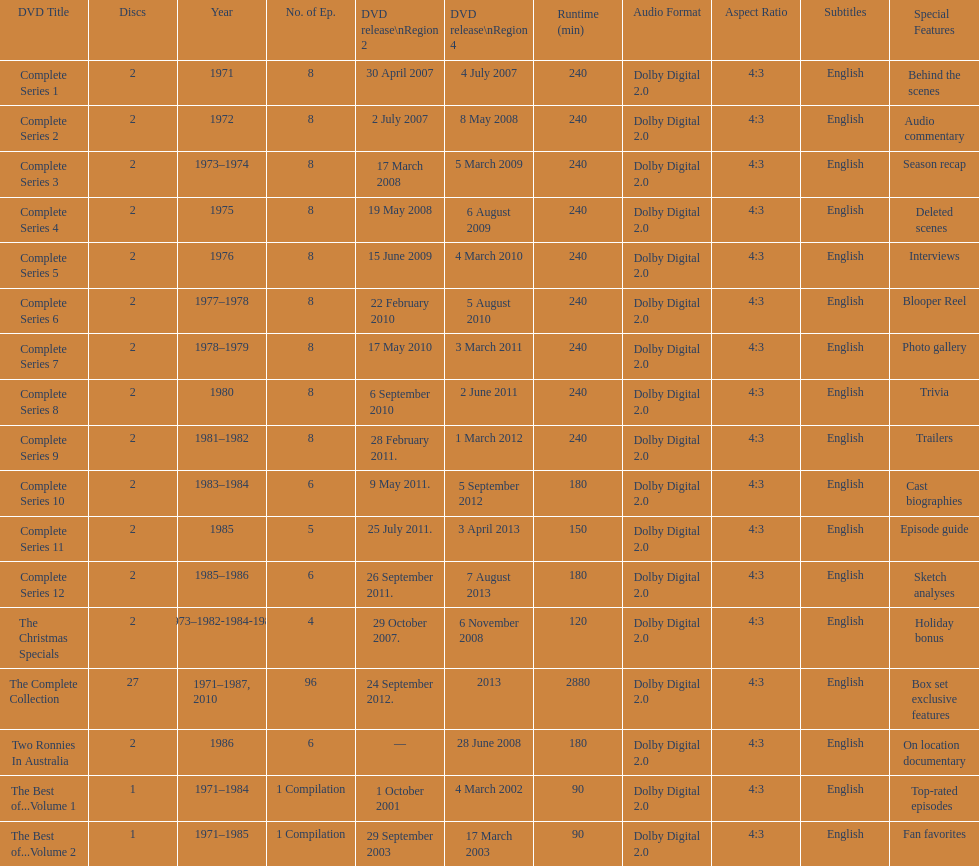The complete collection has 96 episodes, but the christmas specials only has how many episodes? 4. Would you be able to parse every entry in this table? {'header': ['DVD Title', 'Discs', 'Year', 'No. of Ep.', 'DVD release\\nRegion 2', 'DVD release\\nRegion 4', 'Runtime (min)', 'Audio Format', 'Aspect Ratio', 'Subtitles', 'Special Features'], 'rows': [['Complete Series 1', '2', '1971', '8', '30 April 2007', '4 July 2007', '240', 'Dolby Digital 2.0', '4:3', 'English', 'Behind the scenes'], ['Complete Series 2', '2', '1972', '8', '2 July 2007', '8 May 2008', '240', 'Dolby Digital 2.0', '4:3', 'English', 'Audio commentary'], ['Complete Series 3', '2', '1973–1974', '8', '17 March 2008', '5 March 2009', '240', 'Dolby Digital 2.0', '4:3', 'English', 'Season recap'], ['Complete Series 4', '2', '1975', '8', '19 May 2008', '6 August 2009', '240', 'Dolby Digital 2.0', '4:3', 'English', 'Deleted scenes'], ['Complete Series 5', '2', '1976', '8', '15 June 2009', '4 March 2010', '240', 'Dolby Digital 2.0', '4:3', 'English', 'Interviews'], ['Complete Series 6', '2', '1977–1978', '8', '22 February 2010', '5 August 2010', '240', 'Dolby Digital 2.0', '4:3', 'English', 'Blooper Reel'], ['Complete Series 7', '2', '1978–1979', '8', '17 May 2010', '3 March 2011', '240', 'Dolby Digital 2.0', '4:3', 'English', 'Photo gallery'], ['Complete Series 8', '2', '1980', '8', '6 September 2010', '2 June 2011', '240', 'Dolby Digital 2.0', '4:3', 'English', 'Trivia'], ['Complete Series 9', '2', '1981–1982', '8', '28 February 2011.', '1 March 2012', '240', 'Dolby Digital 2.0', '4:3', 'English', 'Trailers'], ['Complete Series 10', '2', '1983–1984', '6', '9 May 2011.', '5 September 2012', '180', 'Dolby Digital 2.0', '4:3', 'English', 'Cast biographies'], ['Complete Series 11', '2', '1985', '5', '25 July 2011.', '3 April 2013', '150', 'Dolby Digital 2.0', '4:3', 'English', 'Episode guide'], ['Complete Series 12', '2', '1985–1986', '6', '26 September 2011.', '7 August 2013', '180', 'Dolby Digital 2.0', '4:3', 'English', 'Sketch analyses'], ['The Christmas Specials', '2', '1973–1982-1984-1987', '4', '29 October 2007.', '6 November 2008', '120', 'Dolby Digital 2.0', '4:3', 'English', 'Holiday bonus'], ['The Complete Collection', '27', '1971–1987, 2010', '96', '24 September 2012.', '2013', '2880', 'Dolby Digital 2.0', '4:3', 'English', 'Box set exclusive features'], ['Two Ronnies In Australia', '2', '1986', '6', '—', '28 June 2008', '180', 'Dolby Digital 2.0', '4:3', 'English', 'On location documentary'], ['The Best of...Volume 1', '1', '1971–1984', '1 Compilation', '1 October 2001', '4 March 2002', '90', 'Dolby Digital 2.0', '4:3', 'English', 'Top-rated episodes'], ['The Best of...Volume 2', '1', '1971–1985', '1 Compilation', '29 September 2003', '17 March 2003', '90', 'Dolby Digital 2.0', '4:3', 'English', 'Fan favorites']]} 